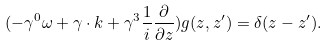Convert formula to latex. <formula><loc_0><loc_0><loc_500><loc_500>( - \gamma ^ { 0 } \omega + \gamma \cdot k + \gamma ^ { 3 } \frac { 1 } { i } \frac { \partial } { \partial z } ) g ( z , z ^ { \prime } ) = \delta ( z - z ^ { \prime } ) .</formula> 